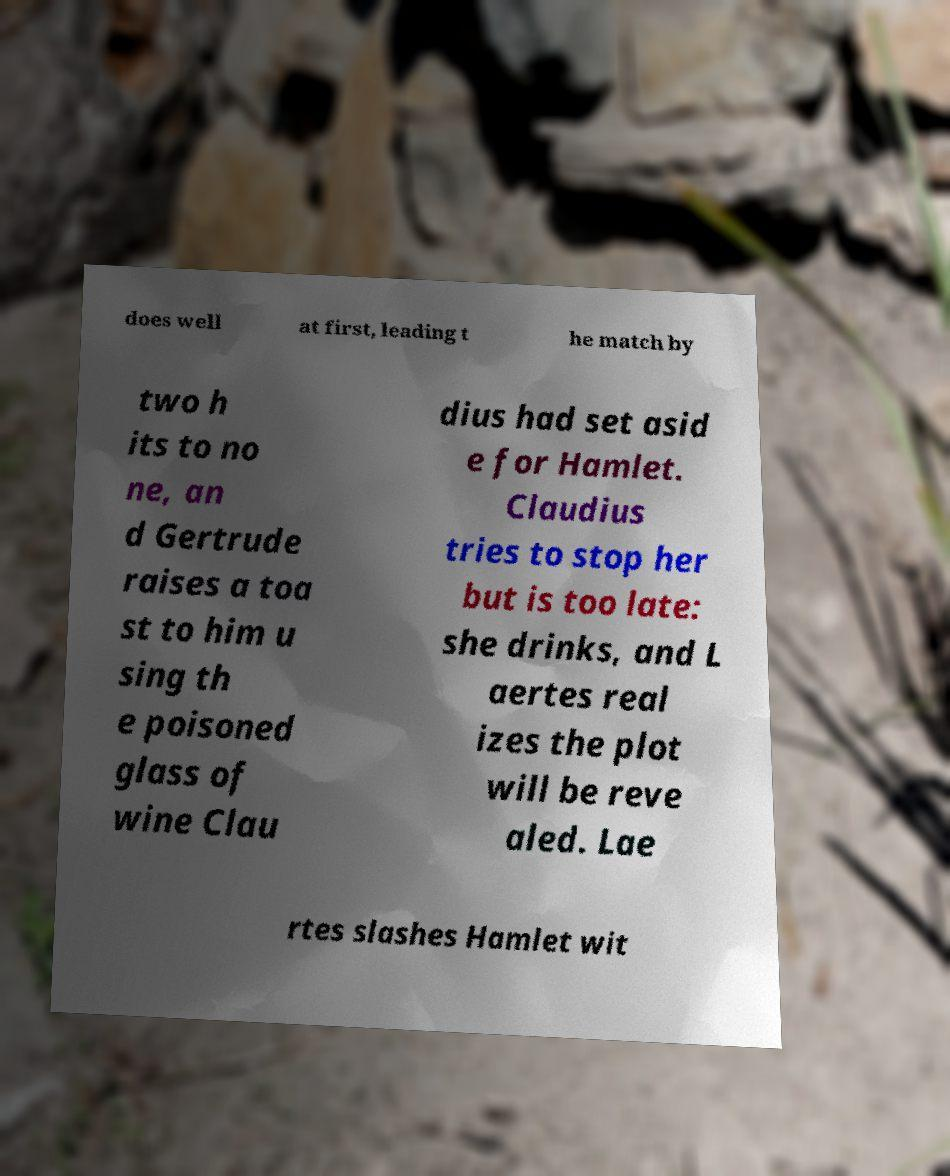Could you extract and type out the text from this image? does well at first, leading t he match by two h its to no ne, an d Gertrude raises a toa st to him u sing th e poisoned glass of wine Clau dius had set asid e for Hamlet. Claudius tries to stop her but is too late: she drinks, and L aertes real izes the plot will be reve aled. Lae rtes slashes Hamlet wit 